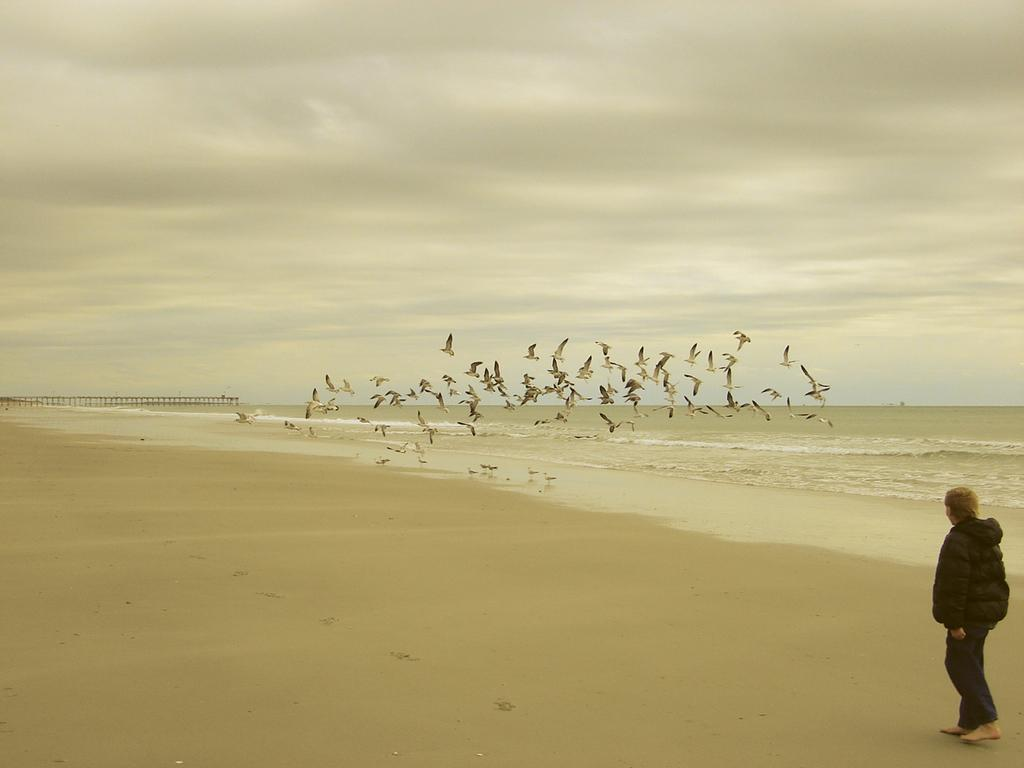What is the person in the image doing? The person in the image is walking on the beach. What can be seen in front of the person? Water is visible in front of the person. Are there any animals present in the image? Yes, birds are present near the water. What is visible in the background of the image? There is a bridge in the background of the image. What type of square object can be seen in the image? There is no square object present in the image. What type of vacation is the person enjoying in the image? The image does not provide information about the person's vacation or any related activities. 